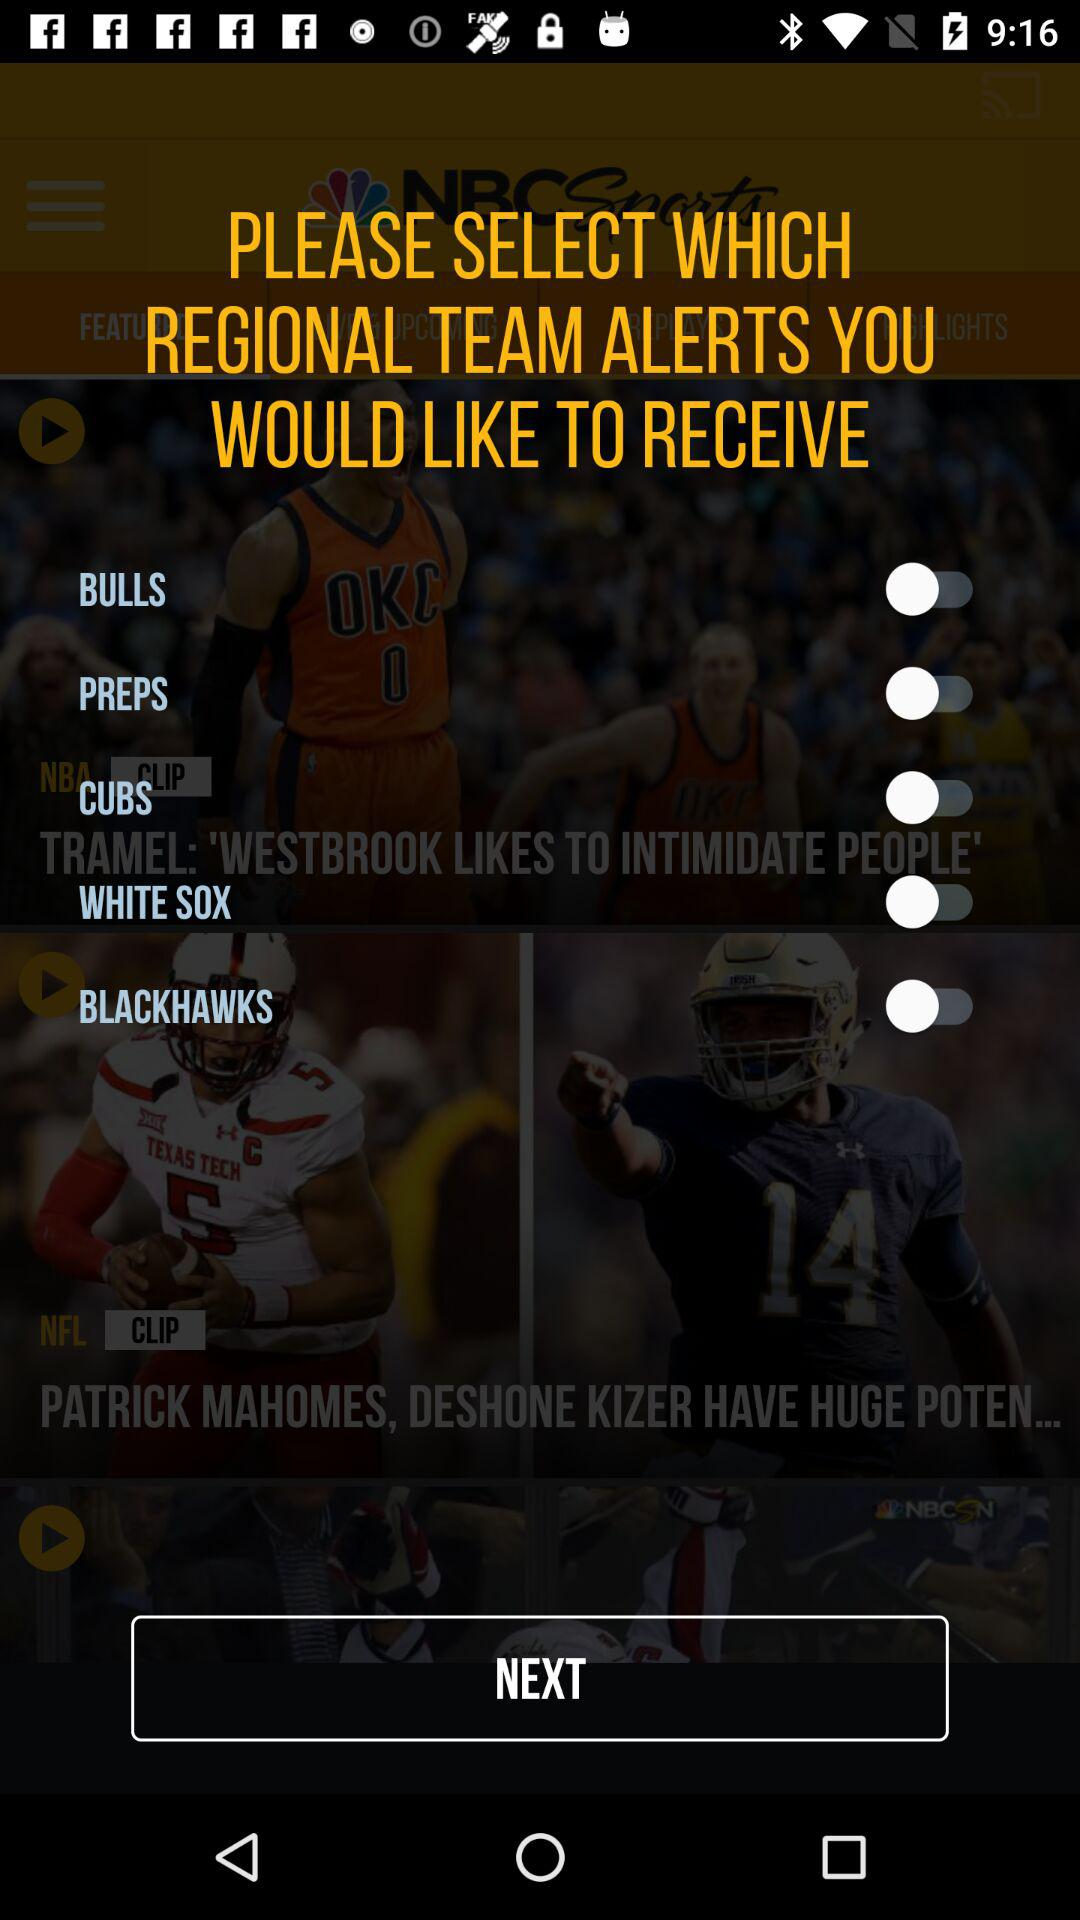What is the username?
When the provided information is insufficient, respond with <no answer>. <no answer> 